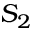Convert formula to latex. <formula><loc_0><loc_0><loc_500><loc_500>S _ { 2 }</formula> 